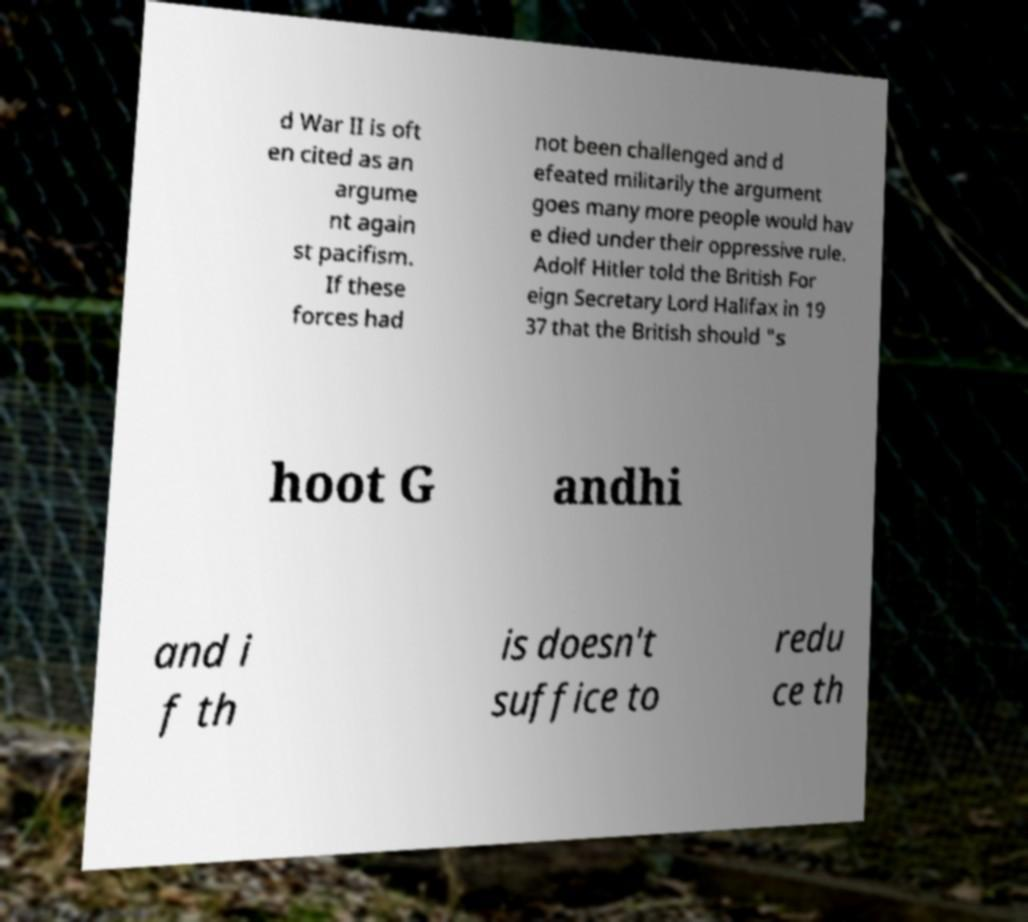I need the written content from this picture converted into text. Can you do that? d War II is oft en cited as an argume nt again st pacifism. If these forces had not been challenged and d efeated militarily the argument goes many more people would hav e died under their oppressive rule. Adolf Hitler told the British For eign Secretary Lord Halifax in 19 37 that the British should "s hoot G andhi and i f th is doesn't suffice to redu ce th 